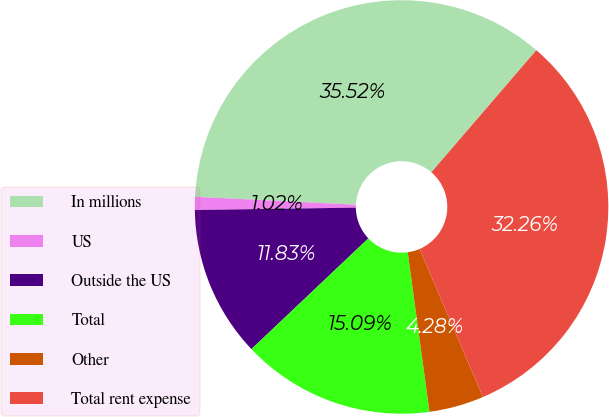Convert chart. <chart><loc_0><loc_0><loc_500><loc_500><pie_chart><fcel>In millions<fcel>US<fcel>Outside the US<fcel>Total<fcel>Other<fcel>Total rent expense<nl><fcel>35.52%<fcel>1.02%<fcel>11.83%<fcel>15.09%<fcel>4.28%<fcel>32.26%<nl></chart> 